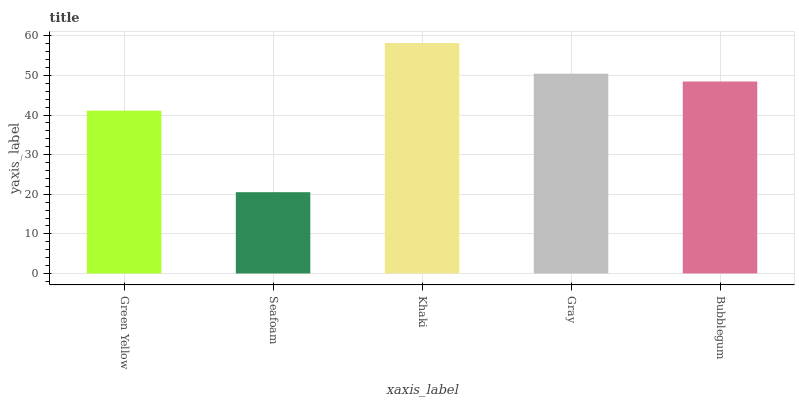Is Seafoam the minimum?
Answer yes or no. Yes. Is Khaki the maximum?
Answer yes or no. Yes. Is Khaki the minimum?
Answer yes or no. No. Is Seafoam the maximum?
Answer yes or no. No. Is Khaki greater than Seafoam?
Answer yes or no. Yes. Is Seafoam less than Khaki?
Answer yes or no. Yes. Is Seafoam greater than Khaki?
Answer yes or no. No. Is Khaki less than Seafoam?
Answer yes or no. No. Is Bubblegum the high median?
Answer yes or no. Yes. Is Bubblegum the low median?
Answer yes or no. Yes. Is Gray the high median?
Answer yes or no. No. Is Green Yellow the low median?
Answer yes or no. No. 